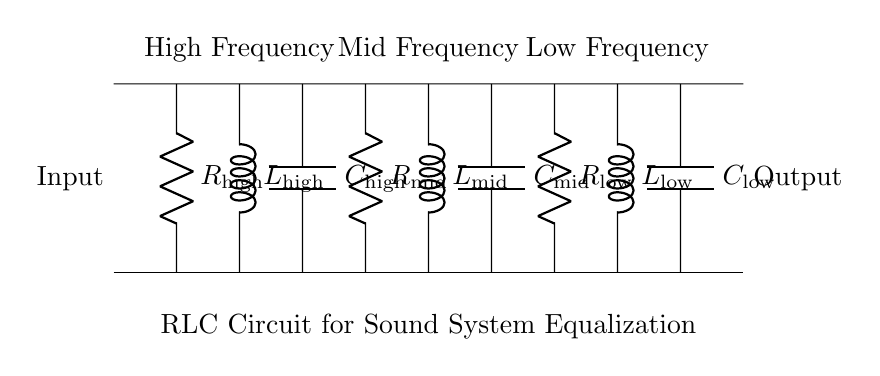What are the components used in this circuit? The circuit includes resistors, inductors, and capacitors, specifically labeled as R, L, and C.
Answer: Resistors, Inductors, Capacitors What type of circuit is represented? The circuit is specifically an RLC circuit, which is characterized by the presence of resistors, inductors, and capacitors.
Answer: RLC circuit How many frequency categories are represented in this circuit? There are three frequency categories labeled as High Frequency, Mid Frequency, and Low Frequency, each with its respective components.
Answer: Three What is the purpose of the circuit? The circuit is designed for sound system equalization, adjusting audio frequencies in a large church sanctuary.
Answer: Sound system equalization Which component is connected to the mid-frequency section? The mid-frequency section includes a resistor, an inductor, and a capacitor all labeled with 'mid' in their names.
Answer: Resistor, Inductor, Capacitor What is the position of the input in relation to the output? The input is on the left side of the circuit diagram, and the output is on the right side, indicating the flow of electrical signals.
Answer: Left side to right side What is the function of inductors in this circuit? Inductors store energy in a magnetic field when electrical current flows through them, affecting impedance at different frequencies.
Answer: Energy storage 